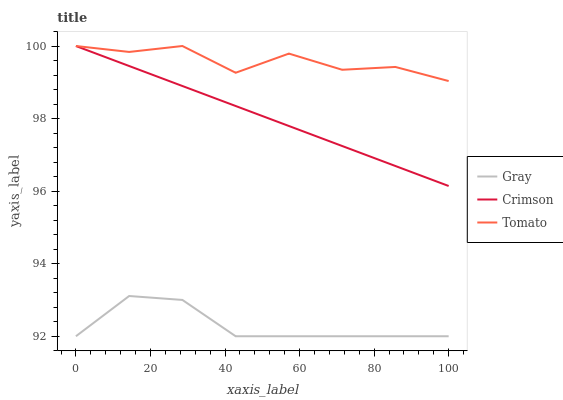Does Gray have the minimum area under the curve?
Answer yes or no. Yes. Does Tomato have the maximum area under the curve?
Answer yes or no. Yes. Does Tomato have the minimum area under the curve?
Answer yes or no. No. Does Gray have the maximum area under the curve?
Answer yes or no. No. Is Crimson the smoothest?
Answer yes or no. Yes. Is Tomato the roughest?
Answer yes or no. Yes. Is Gray the smoothest?
Answer yes or no. No. Is Gray the roughest?
Answer yes or no. No. Does Tomato have the lowest value?
Answer yes or no. No. Does Tomato have the highest value?
Answer yes or no. Yes. Does Gray have the highest value?
Answer yes or no. No. Is Gray less than Tomato?
Answer yes or no. Yes. Is Tomato greater than Gray?
Answer yes or no. Yes. Does Tomato intersect Crimson?
Answer yes or no. Yes. Is Tomato less than Crimson?
Answer yes or no. No. Is Tomato greater than Crimson?
Answer yes or no. No. Does Gray intersect Tomato?
Answer yes or no. No. 